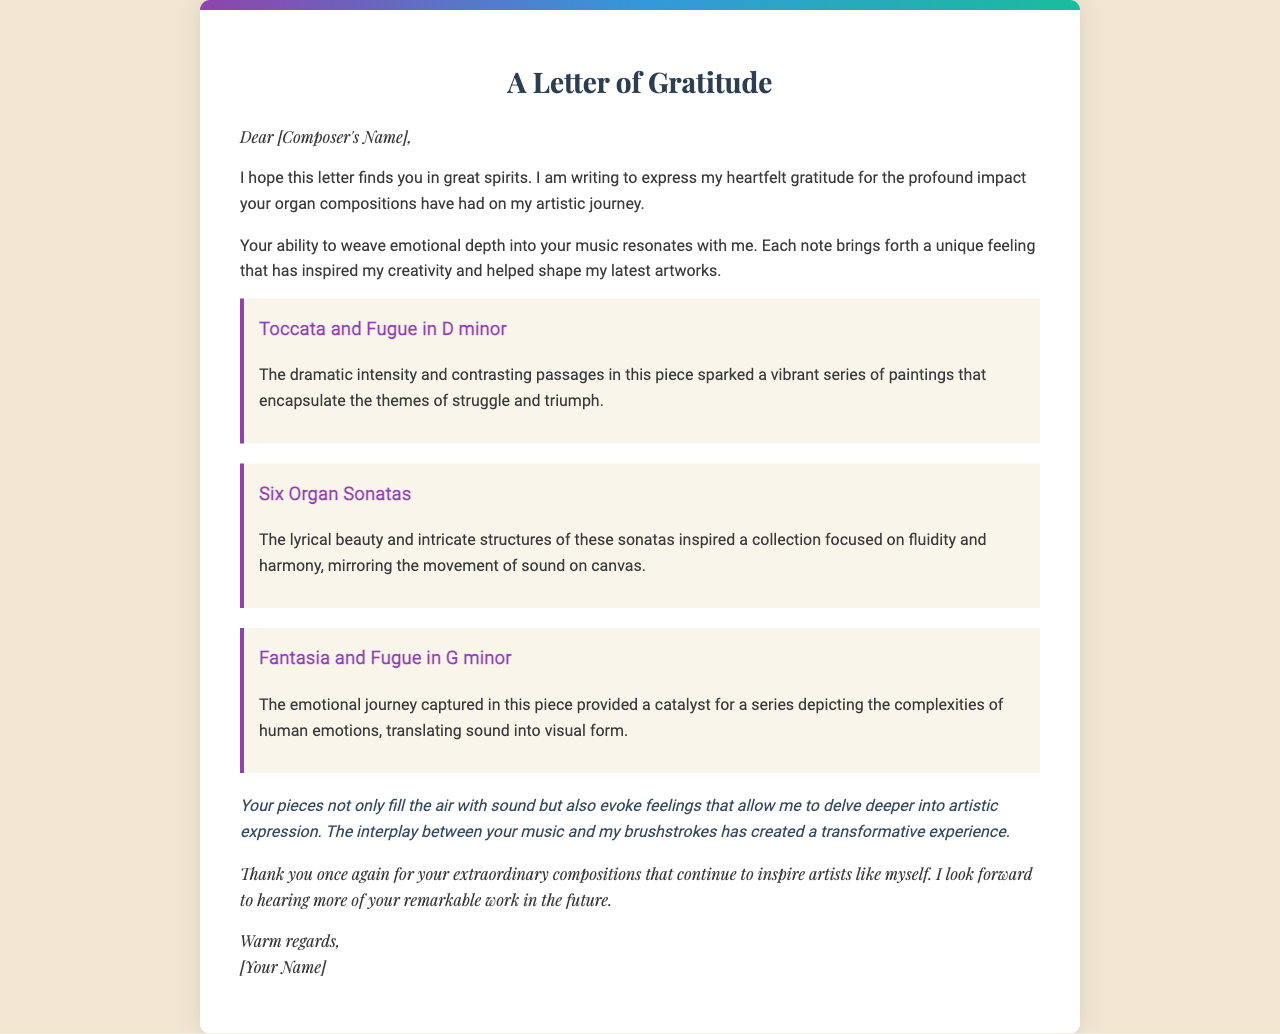What is the title of the letter? The title of the letter is in the heading at the top, which expresses gratitude.
Answer: A Letter of Gratitude Who is the recipient of the letter? The recipient is addressed at the beginning of the letter, indicated by placeholders.
Answer: [Composer's Name] What is the first organ piece mentioned in the letter? The first organ piece is highlighted within a section specifically about musical pieces.
Answer: Toccata and Fugue in D minor What emotion does the "Six Organ Sonatas" inspire? The letter describes specific emotions and themes evoked by the compositions, specifically for this piece.
Answer: Fluidity and harmony How many organ pieces are discussed in the letter? The letter includes multiple mentions of specific organ pieces listed individually.
Answer: Three What is the personal connection expressed in the letter? The writer shares a personal experience regarding how the music impacts their artistic expression in the document.
Answer: Transformative experience What type of writing is this document? The format and style of the content indicate the nature of the correspondence being made.
Answer: Thank you letter What does the writer hope to hear in the future? The closing remarks of the letter express the writer's future expectations regarding the recipient's work.
Answer: More remarkable work 